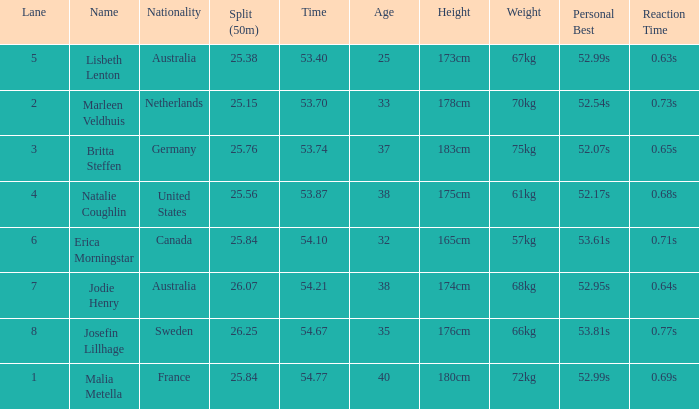What is the total of lane(s) for swimmers from Sweden with a 50m split of faster than 26.25? None. 